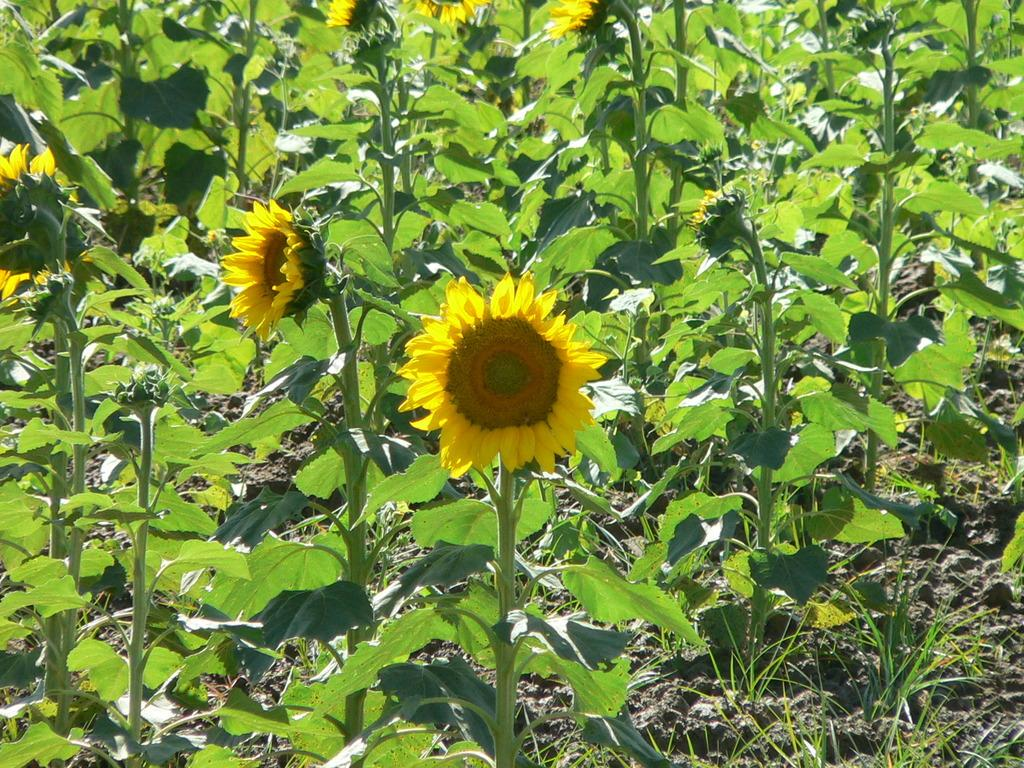What type of living organisms can be seen in the image? Plants can be seen in the image. Do the plants have any specific features? Yes, the plants have flowers. Where are the plants and flowers located in the image? The plants and flowers are on the ground. What type of battle is taking place in the image? There is no battle present in the image; it features plants with flowers on the ground. How many cannons can be seen in the image? There are no cannons present in the image. 